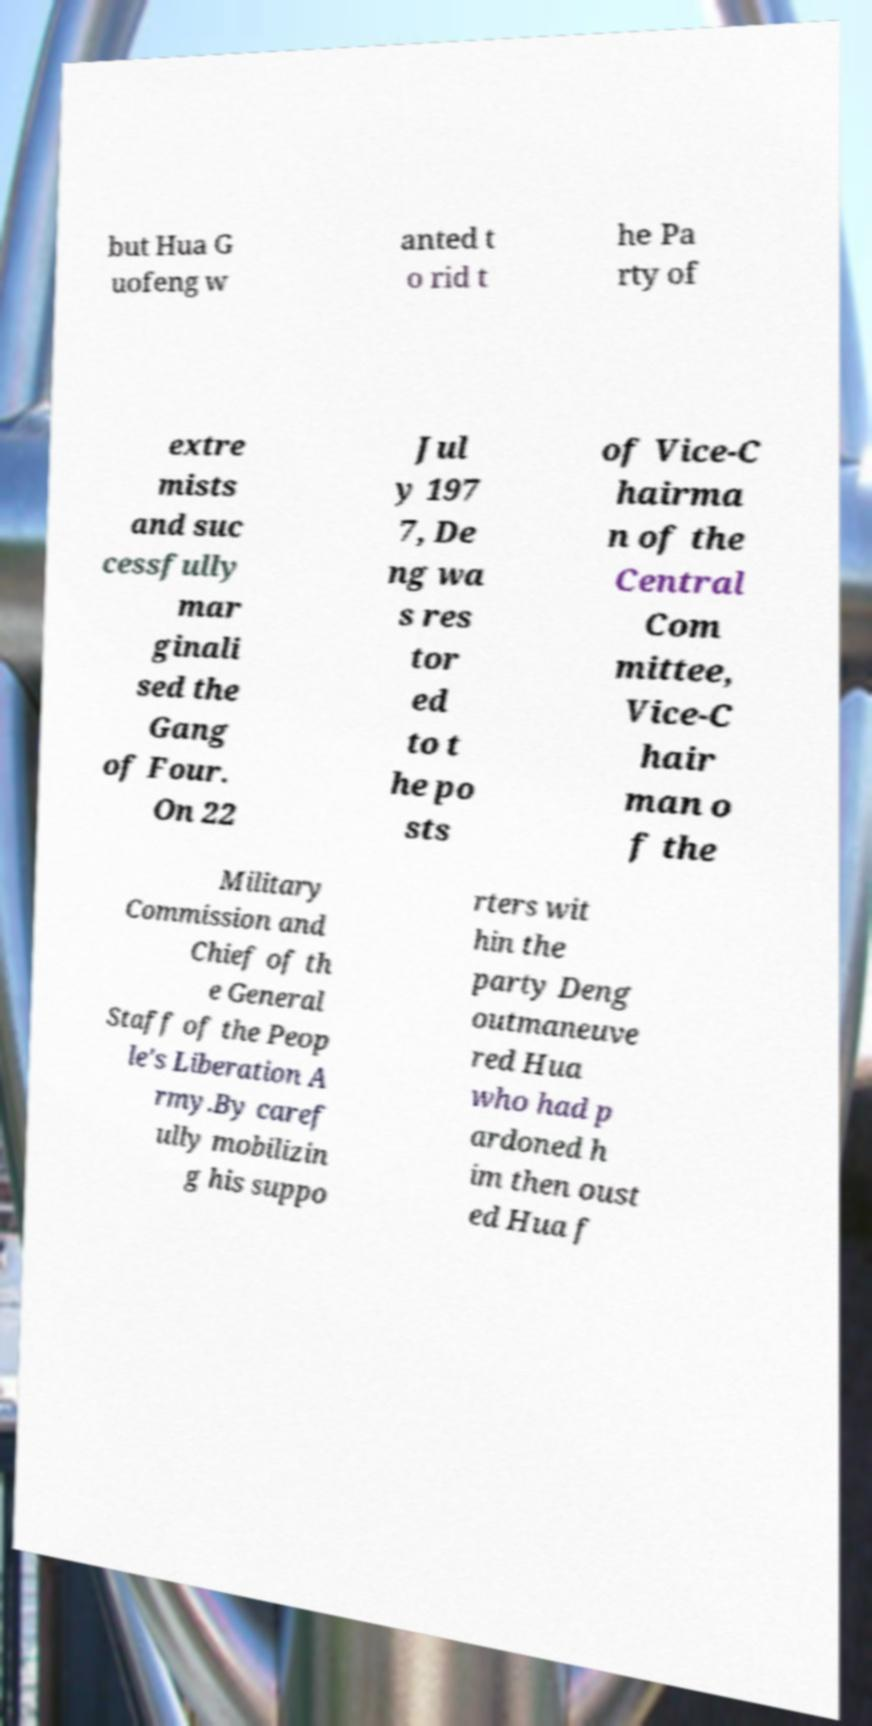Please identify and transcribe the text found in this image. but Hua G uofeng w anted t o rid t he Pa rty of extre mists and suc cessfully mar ginali sed the Gang of Four. On 22 Jul y 197 7, De ng wa s res tor ed to t he po sts of Vice-C hairma n of the Central Com mittee, Vice-C hair man o f the Military Commission and Chief of th e General Staff of the Peop le's Liberation A rmy.By caref ully mobilizin g his suppo rters wit hin the party Deng outmaneuve red Hua who had p ardoned h im then oust ed Hua f 